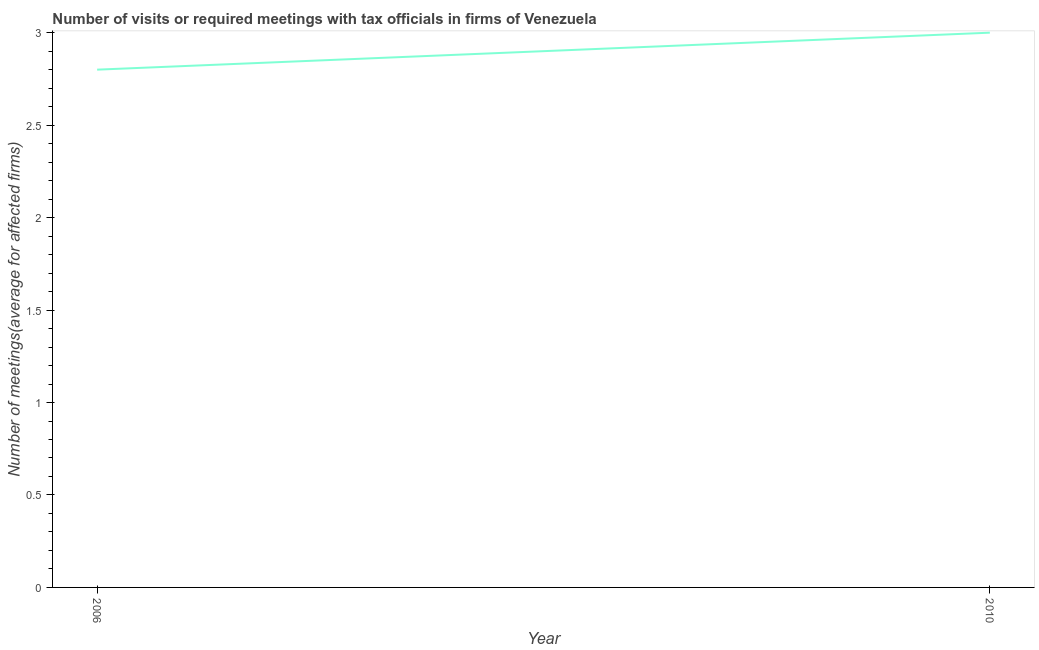What is the number of required meetings with tax officials in 2006?
Provide a short and direct response. 2.8. In which year was the number of required meetings with tax officials minimum?
Your answer should be compact. 2006. What is the sum of the number of required meetings with tax officials?
Offer a very short reply. 5.8. What is the difference between the number of required meetings with tax officials in 2006 and 2010?
Offer a terse response. -0.2. What is the average number of required meetings with tax officials per year?
Offer a very short reply. 2.9. What is the median number of required meetings with tax officials?
Provide a succinct answer. 2.9. What is the ratio of the number of required meetings with tax officials in 2006 to that in 2010?
Offer a very short reply. 0.93. Does the number of required meetings with tax officials monotonically increase over the years?
Offer a very short reply. Yes. What is the difference between two consecutive major ticks on the Y-axis?
Your response must be concise. 0.5. Are the values on the major ticks of Y-axis written in scientific E-notation?
Provide a succinct answer. No. What is the title of the graph?
Ensure brevity in your answer.  Number of visits or required meetings with tax officials in firms of Venezuela. What is the label or title of the Y-axis?
Your answer should be compact. Number of meetings(average for affected firms). What is the Number of meetings(average for affected firms) of 2010?
Make the answer very short. 3. What is the difference between the Number of meetings(average for affected firms) in 2006 and 2010?
Your answer should be compact. -0.2. What is the ratio of the Number of meetings(average for affected firms) in 2006 to that in 2010?
Your answer should be very brief. 0.93. 